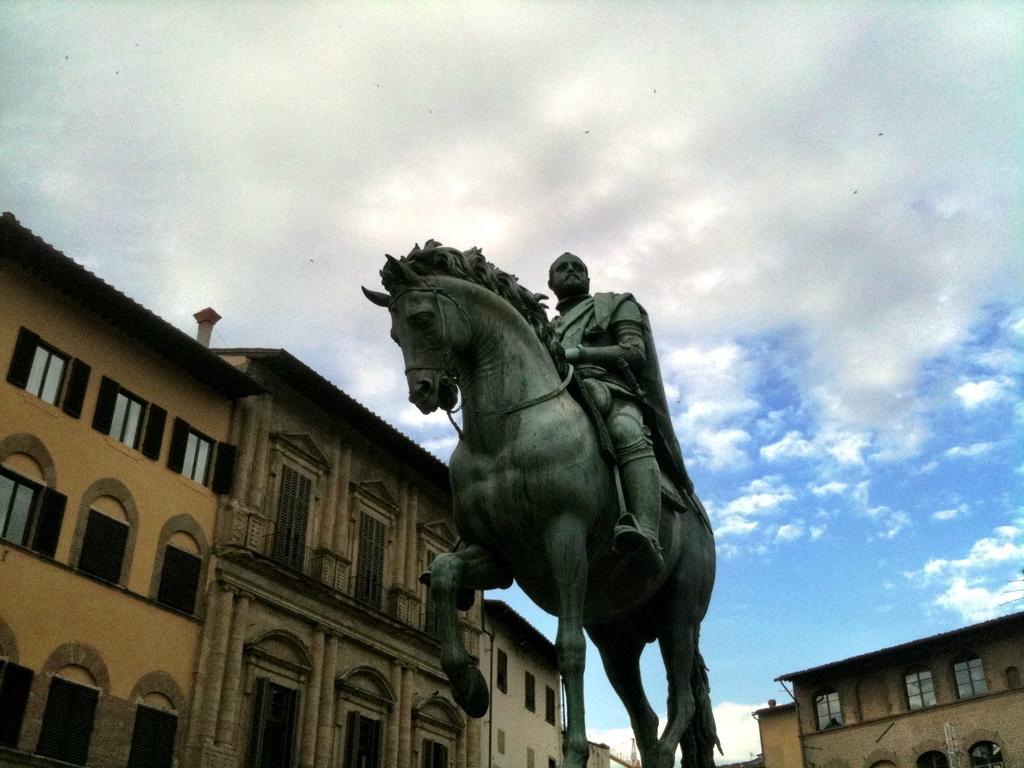In one or two sentences, can you explain what this image depicts? In this image I can see the statue of the person sitting on the animal. In the background I can see the buildings, clouds and the blue sky. 